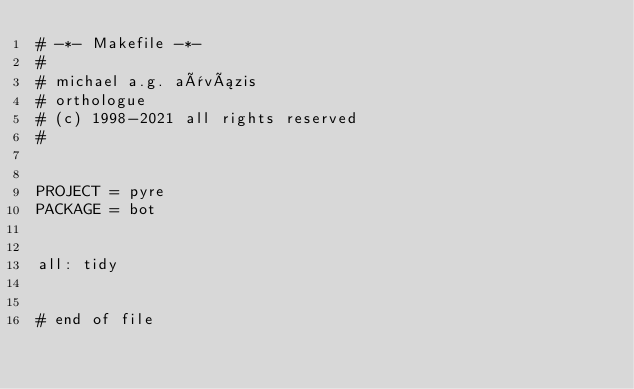Convert code to text. <code><loc_0><loc_0><loc_500><loc_500><_ObjectiveC_># -*- Makefile -*-
#
# michael a.g. aïvázis
# orthologue
# (c) 1998-2021 all rights reserved
#


PROJECT = pyre
PACKAGE = bot


all: tidy


# end of file
</code> 